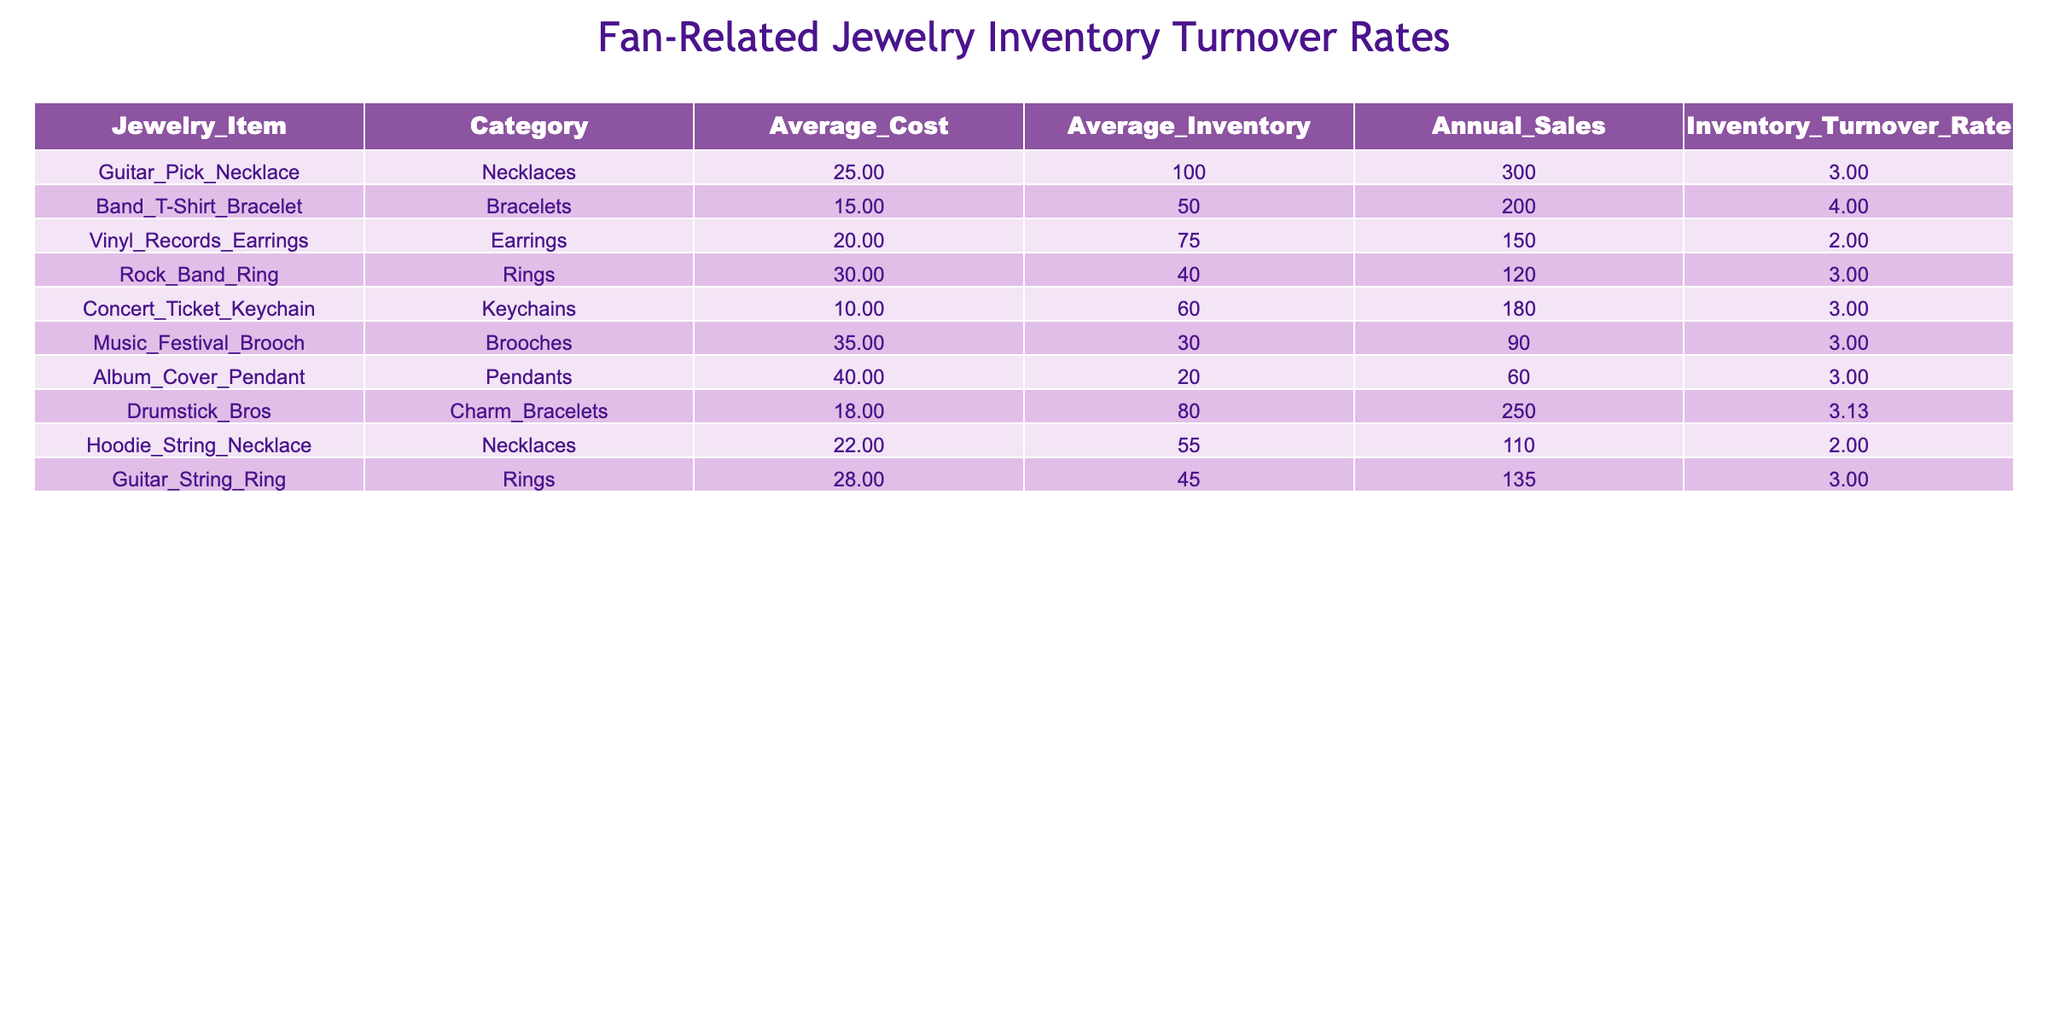What is the average inventory turnover rate for the necklaces category? To find the average turnover rate for the necklaces, we look at the three necklace items: Guitar Pick Necklace (3.00), Hoodie String Necklace (2.00), and their total is 5.00. Then, divide by the number of items, which is 2. Therefore, the average turnover rate is 5.00 / 2 = 2.50.
Answer: 2.50 Which jewelry item has the highest annual sales? The table lists the annual sales for each item. The item with the highest sales is the Drumstick Bros, Charm Bracelets with 250 annual sales, which is greater than any other item.
Answer: 250 Is the inventory turnover rate for the Band T-Shirt Bracelet greater than 4? The Band T-Shirt Bracelet has an inventory turnover rate of 4.00, which is not greater than 4. Therefore, the statement is false.
Answer: No What is the total average inventory across all jewelry items? To find the total average inventory, we sum the average inventory of each item: 100 + 50 + 75 + 40 + 60 + 30 + 20 + 80 + 55 + 45 = 455. Then, divide by the number of items, which is 10. So, the total average inventory is 455 / 10 = 45.5.
Answer: 45.5 How many jewelry items have an inventory turnover rate of exactly 3.00? By examining the table, the items with an inventory turnover rate of 3.00 are: Guitar Pick Necklace, Rock Band Ring, Concert Ticket Keychain, Music Festival Brooch, Album Cover Pendant, Guitar String Ring. This gives us a total of 6 items.
Answer: 6 